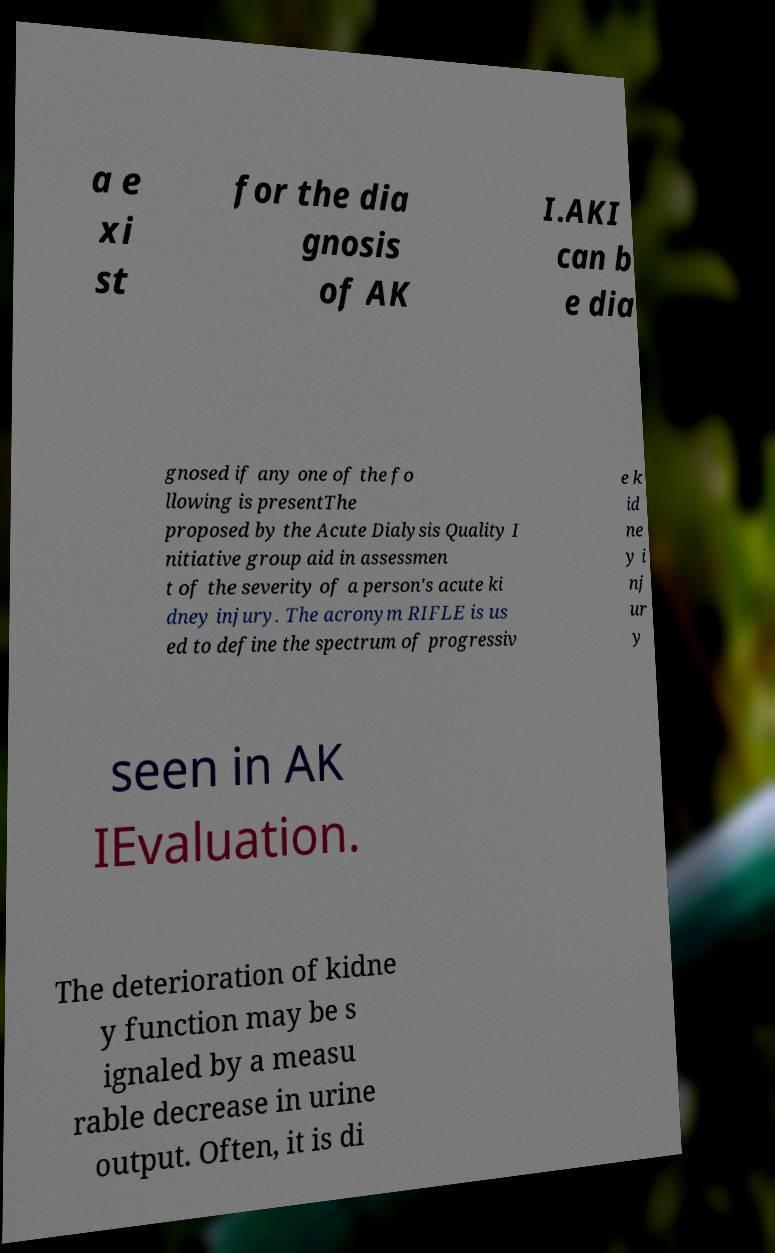Could you assist in decoding the text presented in this image and type it out clearly? a e xi st for the dia gnosis of AK I.AKI can b e dia gnosed if any one of the fo llowing is presentThe proposed by the Acute Dialysis Quality I nitiative group aid in assessmen t of the severity of a person's acute ki dney injury. The acronym RIFLE is us ed to define the spectrum of progressiv e k id ne y i nj ur y seen in AK IEvaluation. The deterioration of kidne y function may be s ignaled by a measu rable decrease in urine output. Often, it is di 